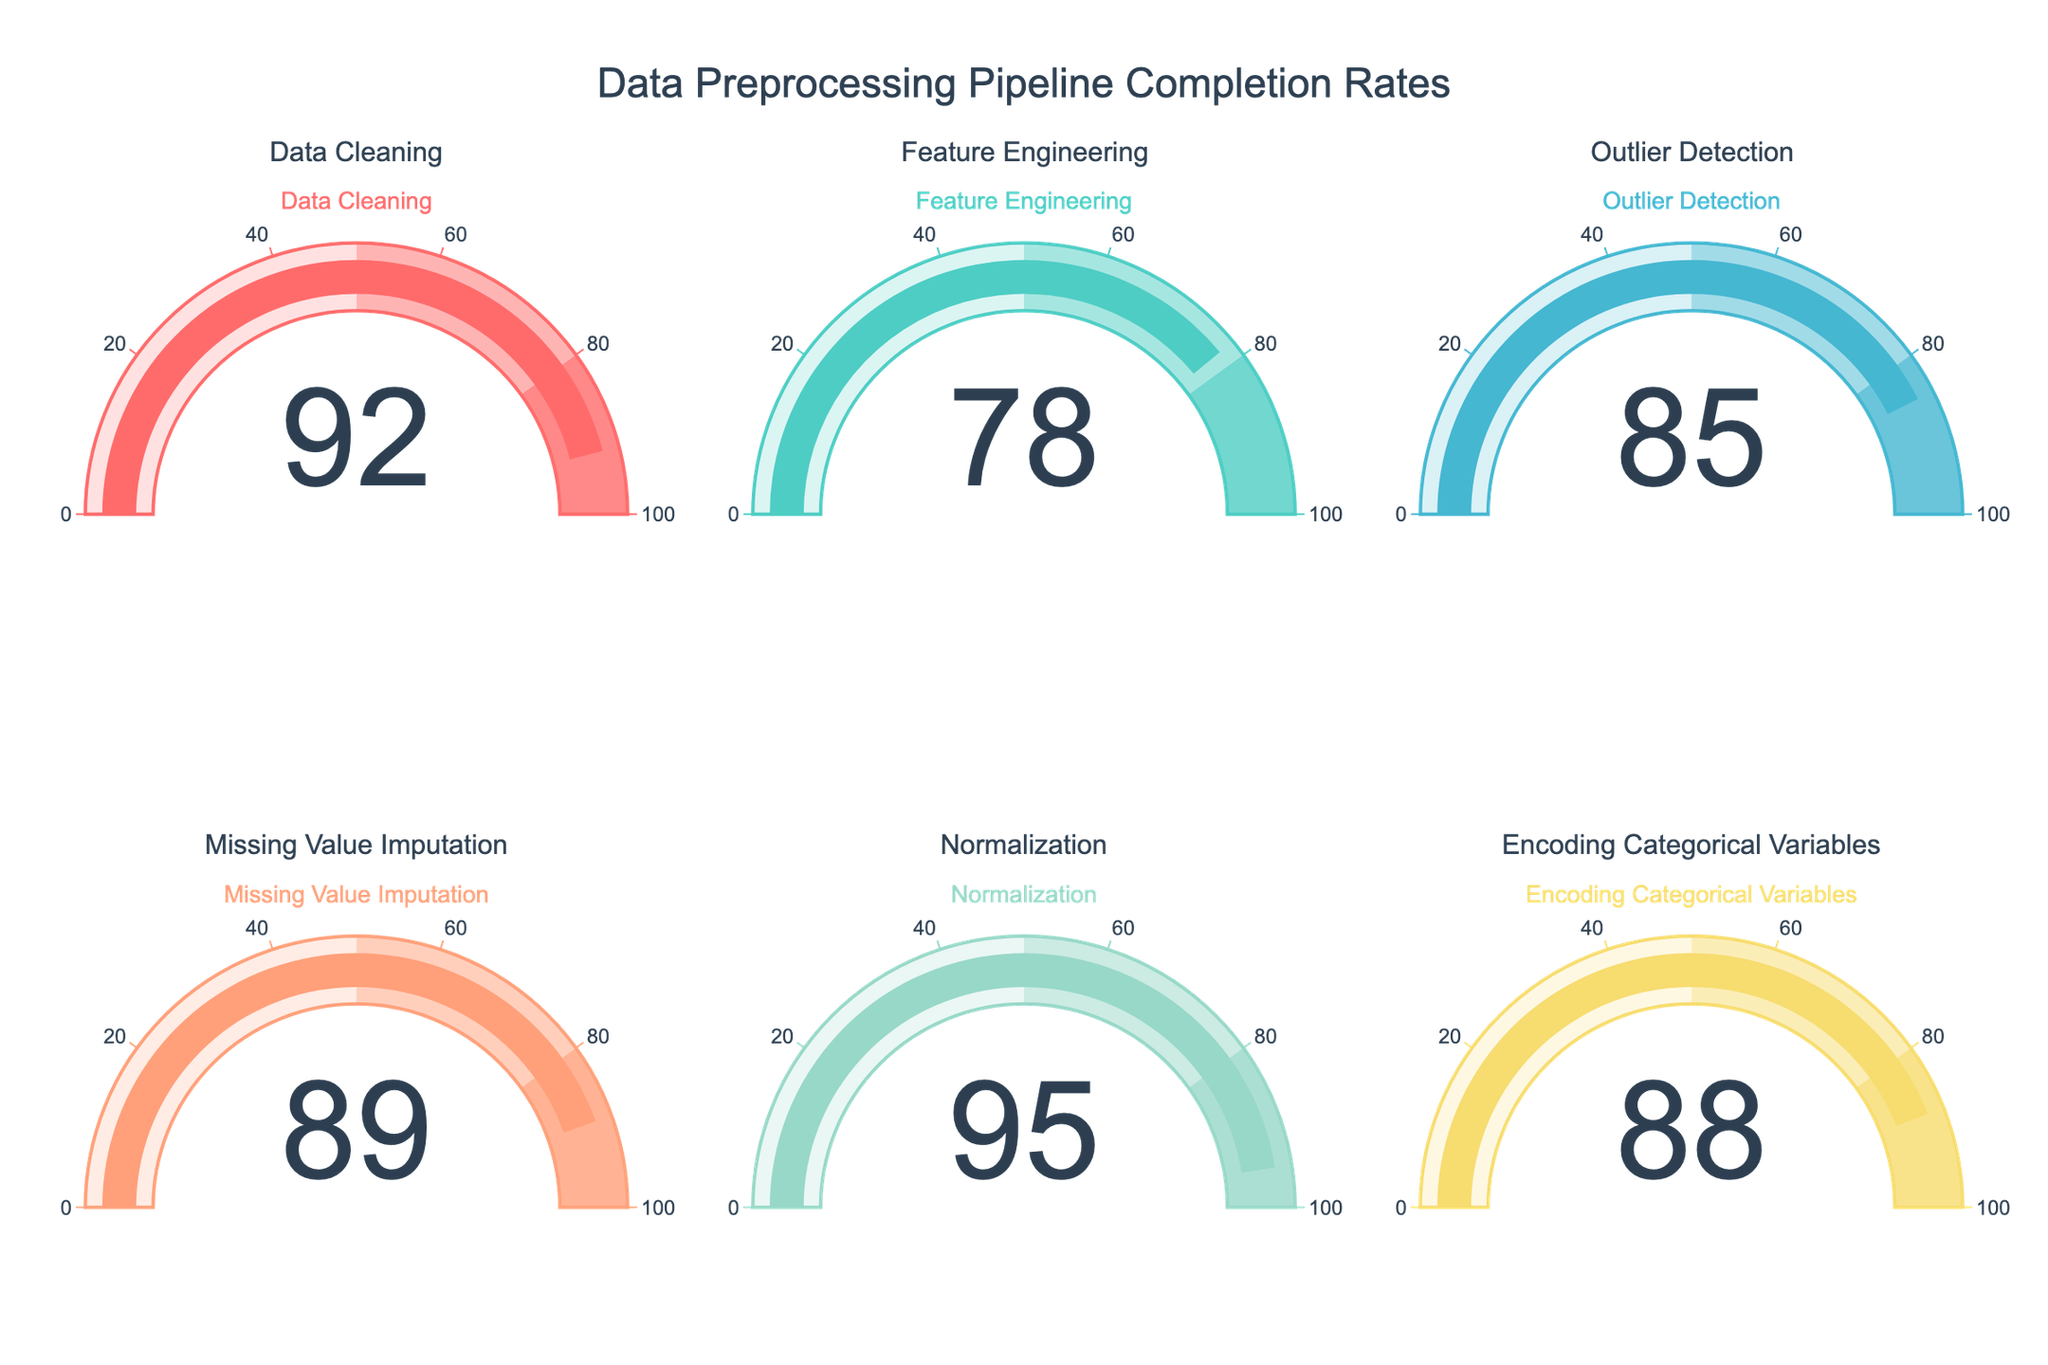What's the title of the gauge chart figure? The title can be found at the top of the figure. It reads "Data Preprocessing Pipeline Completion Rates".
Answer: Data Preprocessing Pipeline Completion Rates How many stages are being displayed in the figure? By counting the individual gauge charts, we can determine there are six stages displayed.
Answer: 6 Which stage has the highest completion rate? By comparing all the values in the gauge charts, the "Normalization" stage has the highest completion rate with 95%.
Answer: Normalization What's the completion rate for the Feature Engineering stage? Locate the Feature Engineering stage and read the value from the gauge chart, which is 78%.
Answer: 78% What is the average completion rate across all stages? Add up all the rates and divide by the number of stages. (0.92 + 0.78 + 0.85 + 0.89 + 0.95 + 0.88) / 6 = 0.8783 or 87.83%
Answer: 87.83% Which stage has the lowest completion rate? By examining all the gauge charts, the "Feature Engineering" stage has the lowest completion rate at 78%.
Answer: Feature Engineering What two stages together have their completion rates summing up to around 1.77? By adding the rates of different pairs, we find that "Outlier Detection" (0.85) and "Missing Value Imputation" (0.89) sum up to 1.74, which is close to 1.77. No exact match, hence 1.74.
Answer: Outlier Detection and Missing Value Imputation Which stages have a completion rate greater than 85%? Identify the stages with completion rates above 85%: "Data Cleaning" (92%), "Outlier Detection" (85%), "Missing Value Imputation" (89%), "Normalization" (95%), and "Encoding Categorical Variables" (88%).
Answer: Data Cleaning, Outlier Detection, Missing Value Imputation, Normalization, Encoding Categorical Variables What is the difference in completion rates between Data Cleaning and Feature Engineering? Subtract the rate of Feature Engineering from Data Cleaning: 0.92 - 0.78 = 0.14 or 14%.
Answer: 14% Which stage has a completion rate closest to 0.90? Compare each completion rate to 0.90 to find the closest. "Missing Value Imputation" with 89% is the closest to 0.90.
Answer: Missing Value Imputation 